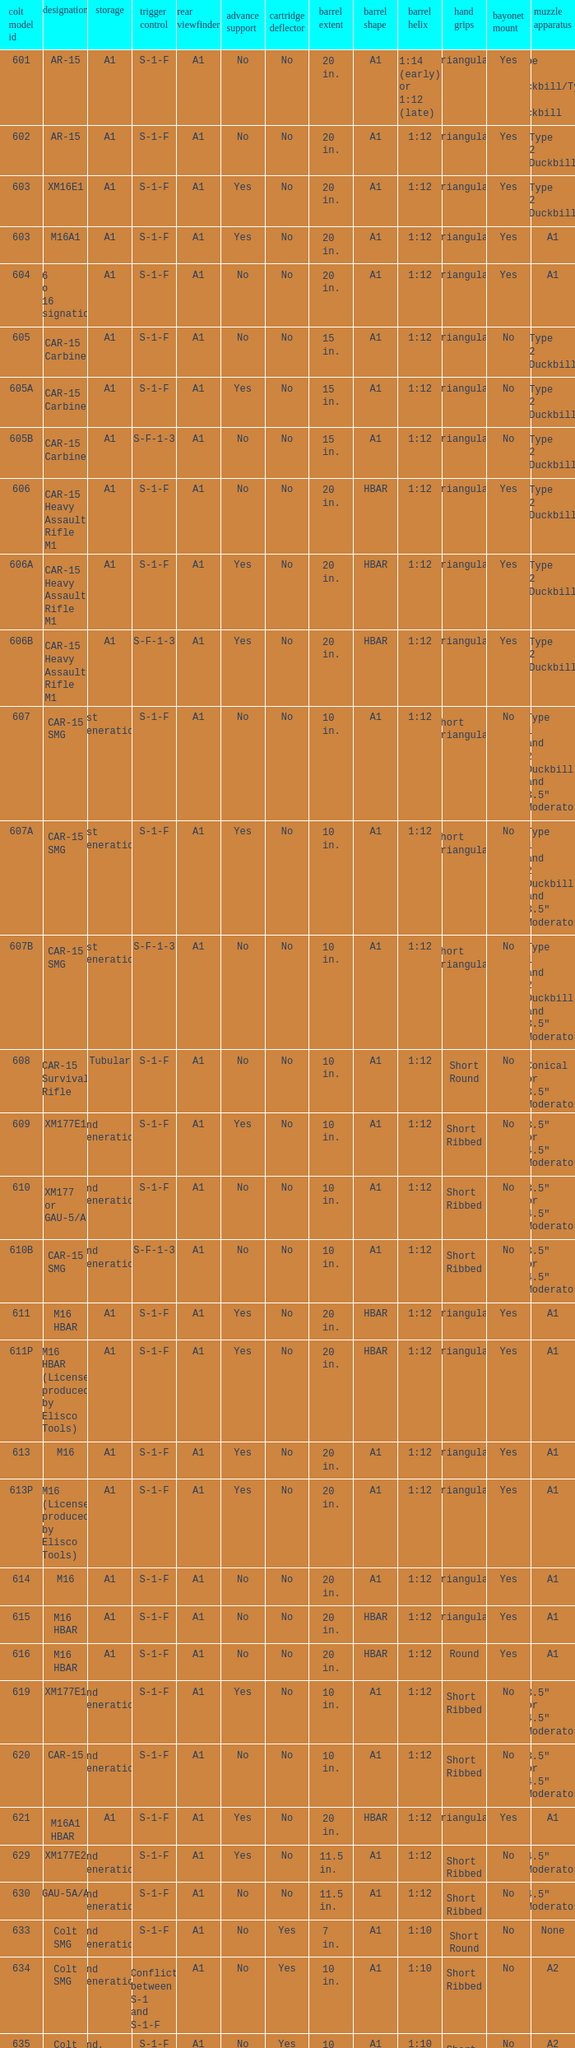What is the rear sight in the Cole model no. 735? A1 or A2. 